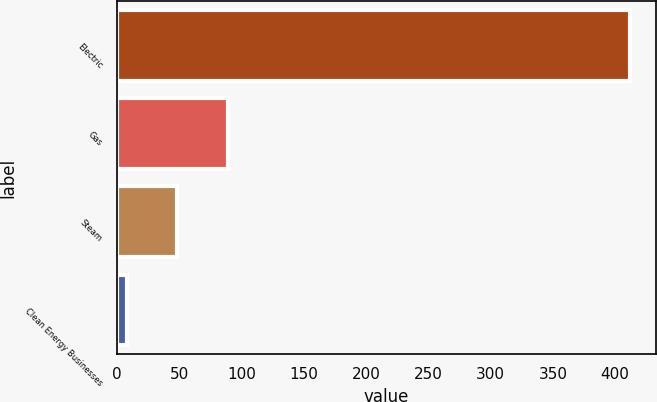<chart> <loc_0><loc_0><loc_500><loc_500><bar_chart><fcel>Electric<fcel>Gas<fcel>Steam<fcel>Clean Energy Businesses<nl><fcel>412<fcel>89<fcel>48.4<fcel>8<nl></chart> 